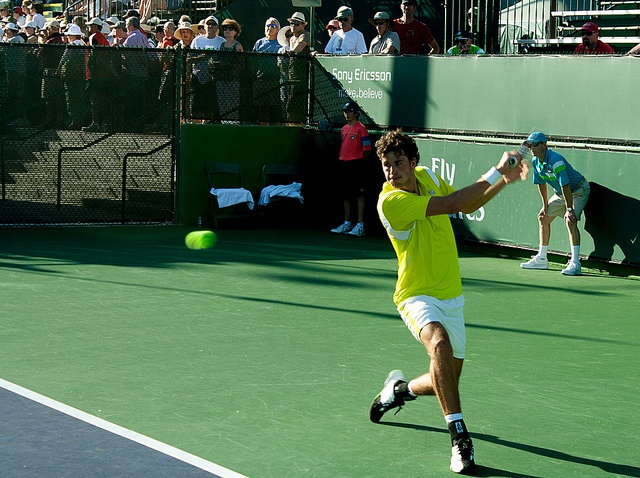Describe the objects in this image and their specific colors. I can see people in darkgray, black, gray, and green tones, people in darkgray, olive, black, ivory, and teal tones, people in darkgray, black, teal, olive, and gray tones, people in darkgray, black, maroon, brown, and blue tones, and people in darkgray, black, blue, white, and navy tones in this image. 